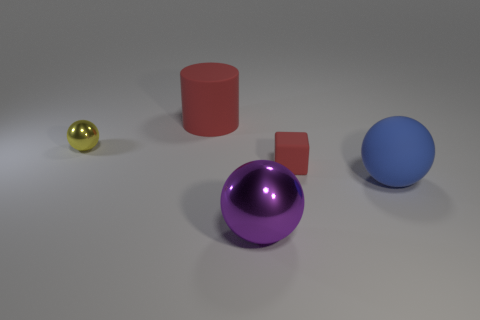Add 1 large cyan cubes. How many objects exist? 6 Subtract all cylinders. How many objects are left? 4 Subtract 0 yellow cylinders. How many objects are left? 5 Subtract all yellow metallic cylinders. Subtract all balls. How many objects are left? 2 Add 5 big matte cylinders. How many big matte cylinders are left? 6 Add 2 tiny cubes. How many tiny cubes exist? 3 